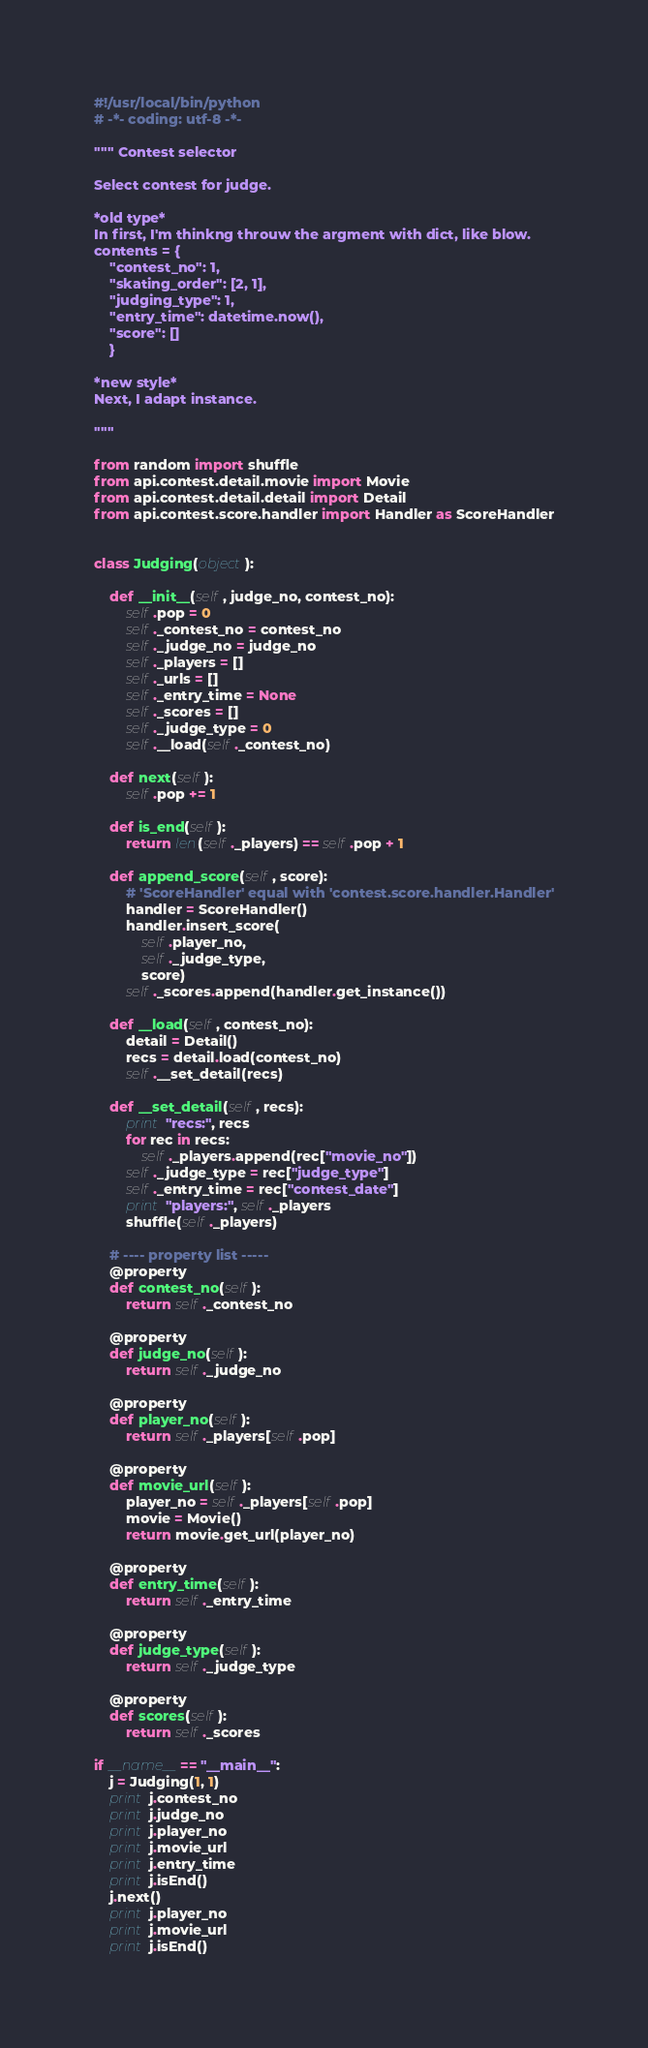<code> <loc_0><loc_0><loc_500><loc_500><_Python_>#!/usr/local/bin/python
# -*- coding: utf-8 -*-

""" Contest selector

Select contest for judge.

*old type*
In first, I'm thinkng throuw the argment with dict, like blow.
contents = {
    "contest_no": 1,
    "skating_order": [2, 1],
    "judging_type": 1,
    "entry_time": datetime.now(),
    "score": []
    }

*new style*
Next, I adapt instance.

"""

from random import shuffle
from api.contest.detail.movie import Movie
from api.contest.detail.detail import Detail
from api.contest.score.handler import Handler as ScoreHandler


class Judging(object):

    def __init__(self, judge_no, contest_no):
        self.pop = 0
        self._contest_no = contest_no
        self._judge_no = judge_no
        self._players = []
        self._urls = []
        self._entry_time = None
        self._scores = []
        self._judge_type = 0
        self.__load(self._contest_no)

    def next(self):
        self.pop += 1

    def is_end(self):
        return len(self._players) == self.pop + 1

    def append_score(self, score):
        # 'ScoreHandler' equal with 'contest.score.handler.Handler'
        handler = ScoreHandler()
        handler.insert_score(
            self.player_no,
            self._judge_type,
            score)
        self._scores.append(handler.get_instance())

    def __load(self, contest_no):
        detail = Detail()
        recs = detail.load(contest_no)
        self.__set_detail(recs)

    def __set_detail(self, recs):
        print "recs:", recs
        for rec in recs:
            self._players.append(rec["movie_no"])
        self._judge_type = rec["judge_type"]
        self._entry_time = rec["contest_date"]
        print "players:", self._players
        shuffle(self._players)

    # ---- property list -----
    @property
    def contest_no(self):
        return self._contest_no

    @property
    def judge_no(self):
        return self._judge_no

    @property
    def player_no(self):
        return self._players[self.pop]

    @property
    def movie_url(self):
        player_no = self._players[self.pop]
        movie = Movie()
        return movie.get_url(player_no)

    @property
    def entry_time(self):
        return self._entry_time

    @property
    def judge_type(self):
        return self._judge_type

    @property
    def scores(self):
        return self._scores

if __name__ == "__main__":
    j = Judging(1, 1)
    print j.contest_no
    print j.judge_no
    print j.player_no
    print j.movie_url
    print j.entry_time
    print j.isEnd()
    j.next()
    print j.player_no
    print j.movie_url
    print j.isEnd()
</code> 